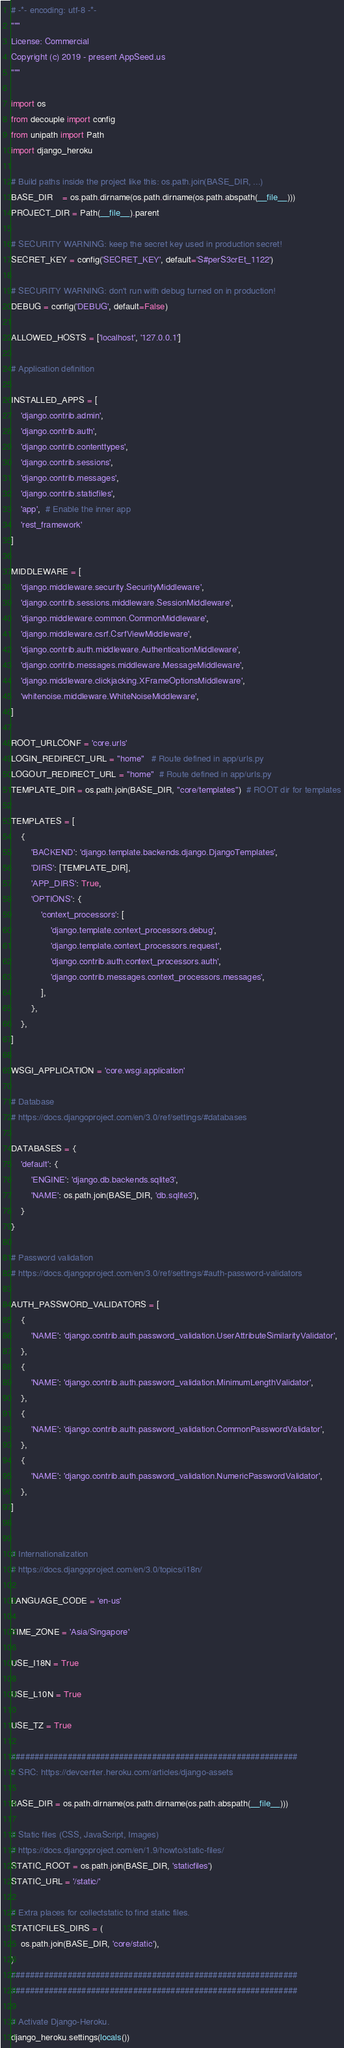<code> <loc_0><loc_0><loc_500><loc_500><_Python_># -*- encoding: utf-8 -*-
"""
License: Commercial
Copyright (c) 2019 - present AppSeed.us
"""

import os
from decouple import config
from unipath import Path
import django_heroku

# Build paths inside the project like this: os.path.join(BASE_DIR, ...)
BASE_DIR    = os.path.dirname(os.path.dirname(os.path.abspath(__file__)))
PROJECT_DIR = Path(__file__).parent

# SECURITY WARNING: keep the secret key used in production secret!
SECRET_KEY = config('SECRET_KEY', default='S#perS3crEt_1122')

# SECURITY WARNING: don't run with debug turned on in production!
DEBUG = config('DEBUG', default=False)

ALLOWED_HOSTS = ['localhost', '127.0.0.1']

# Application definition

INSTALLED_APPS = [
    'django.contrib.admin',
    'django.contrib.auth',
    'django.contrib.contenttypes',
    'django.contrib.sessions',
    'django.contrib.messages',
    'django.contrib.staticfiles',
    'app',  # Enable the inner app
    'rest_framework'
]

MIDDLEWARE = [
    'django.middleware.security.SecurityMiddleware',
    'django.contrib.sessions.middleware.SessionMiddleware',
    'django.middleware.common.CommonMiddleware',
    'django.middleware.csrf.CsrfViewMiddleware',
    'django.contrib.auth.middleware.AuthenticationMiddleware',
    'django.contrib.messages.middleware.MessageMiddleware',
    'django.middleware.clickjacking.XFrameOptionsMiddleware',
    'whitenoise.middleware.WhiteNoiseMiddleware',
]

ROOT_URLCONF = 'core.urls'
LOGIN_REDIRECT_URL = "home"   # Route defined in app/urls.py
LOGOUT_REDIRECT_URL = "home"  # Route defined in app/urls.py
TEMPLATE_DIR = os.path.join(BASE_DIR, "core/templates")  # ROOT dir for templates

TEMPLATES = [
    {
        'BACKEND': 'django.template.backends.django.DjangoTemplates',
        'DIRS': [TEMPLATE_DIR],
        'APP_DIRS': True,
        'OPTIONS': {
            'context_processors': [
                'django.template.context_processors.debug',
                'django.template.context_processors.request',
                'django.contrib.auth.context_processors.auth',
                'django.contrib.messages.context_processors.messages',
            ],
        },
    },
]

WSGI_APPLICATION = 'core.wsgi.application'

# Database
# https://docs.djangoproject.com/en/3.0/ref/settings/#databases

DATABASES = {
    'default': {
        'ENGINE': 'django.db.backends.sqlite3',
        'NAME': os.path.join(BASE_DIR, 'db.sqlite3'),
    }
}

# Password validation
# https://docs.djangoproject.com/en/3.0/ref/settings/#auth-password-validators

AUTH_PASSWORD_VALIDATORS = [
    {
        'NAME': 'django.contrib.auth.password_validation.UserAttributeSimilarityValidator',
    },
    {
        'NAME': 'django.contrib.auth.password_validation.MinimumLengthValidator',
    },
    {
        'NAME': 'django.contrib.auth.password_validation.CommonPasswordValidator',
    },
    {
        'NAME': 'django.contrib.auth.password_validation.NumericPasswordValidator',
    },
]


# Internationalization
# https://docs.djangoproject.com/en/3.0/topics/i18n/

LANGUAGE_CODE = 'en-us'

TIME_ZONE = 'Asia/Singapore'

USE_I18N = True

USE_L10N = True

USE_TZ = True

#############################################################
# SRC: https://devcenter.heroku.com/articles/django-assets

BASE_DIR = os.path.dirname(os.path.dirname(os.path.abspath(__file__)))

# Static files (CSS, JavaScript, Images)
# https://docs.djangoproject.com/en/1.9/howto/static-files/
STATIC_ROOT = os.path.join(BASE_DIR, 'staticfiles')
STATIC_URL = '/static/'

# Extra places for collectstatic to find static files.
STATICFILES_DIRS = (
    os.path.join(BASE_DIR, 'core/static'),
)
#############################################################
#############################################################

# Activate Django-Heroku.
django_heroku.settings(locals())
</code> 